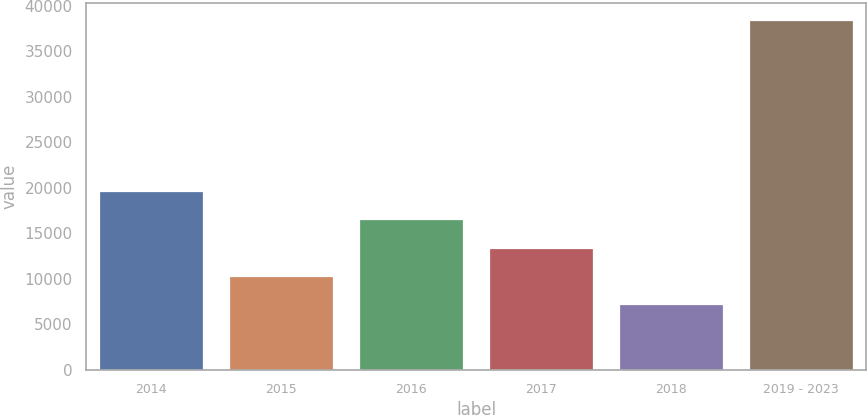Convert chart to OTSL. <chart><loc_0><loc_0><loc_500><loc_500><bar_chart><fcel>2014<fcel>2015<fcel>2016<fcel>2017<fcel>2018<fcel>2019 - 2023<nl><fcel>19660.4<fcel>10294.1<fcel>16538.3<fcel>13416.2<fcel>7172<fcel>38393<nl></chart> 